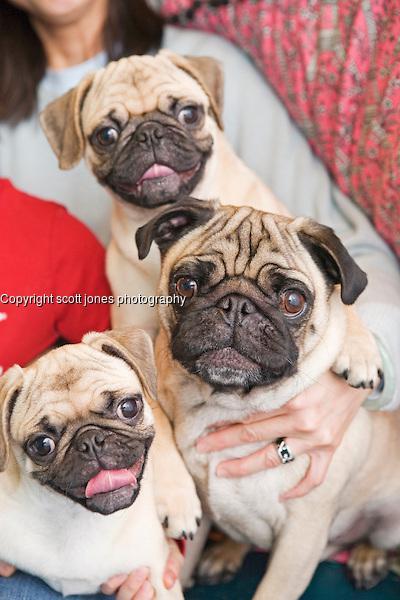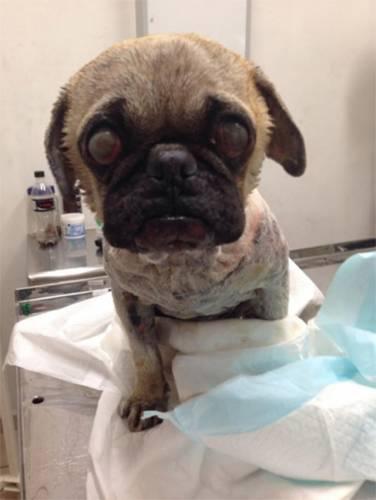The first image is the image on the left, the second image is the image on the right. Examine the images to the left and right. Is the description "Not even one dog has it's mouth open." accurate? Answer yes or no. No. The first image is the image on the left, the second image is the image on the right. Considering the images on both sides, is "Each image contains a single pug which faces forward, and the pug on the right wears something in addition to a collar." valid? Answer yes or no. No. 